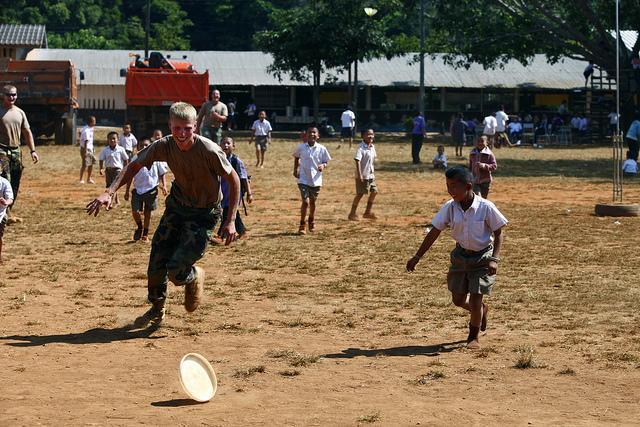How many trucks are in the photo?
Give a very brief answer. 2. How many people are there?
Give a very brief answer. 4. How many benches are on the left of the room?
Give a very brief answer. 0. 